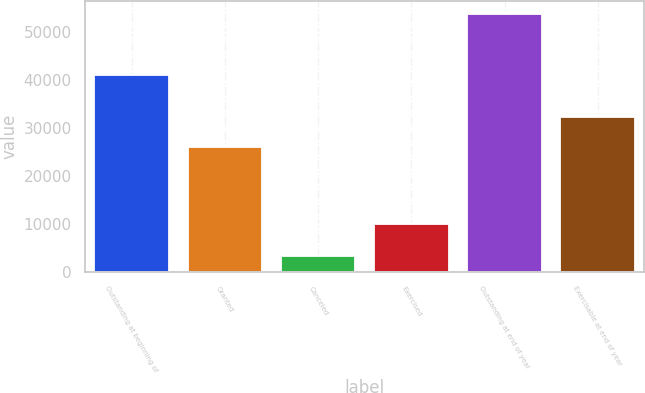<chart> <loc_0><loc_0><loc_500><loc_500><bar_chart><fcel>Outstanding at beginning of<fcel>Granted<fcel>Canceled<fcel>Exercised<fcel>Outstanding at end of year<fcel>Exercisable at end of year<nl><fcel>40969<fcel>26121<fcel>3425<fcel>9981<fcel>53684<fcel>32250<nl></chart> 